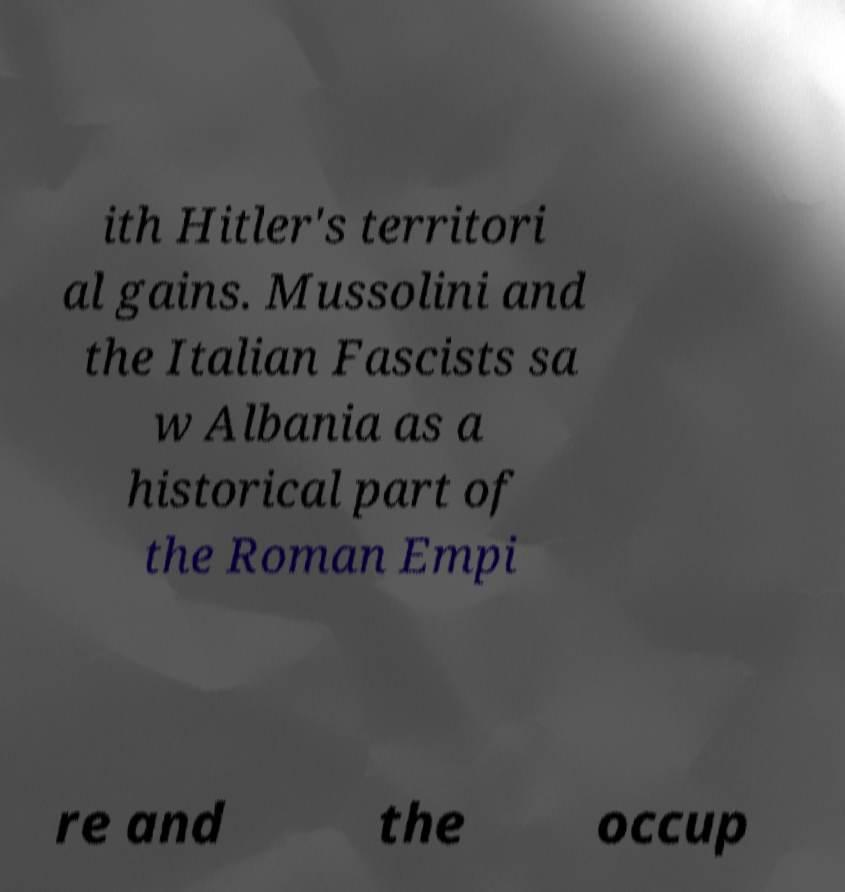For documentation purposes, I need the text within this image transcribed. Could you provide that? ith Hitler's territori al gains. Mussolini and the Italian Fascists sa w Albania as a historical part of the Roman Empi re and the occup 